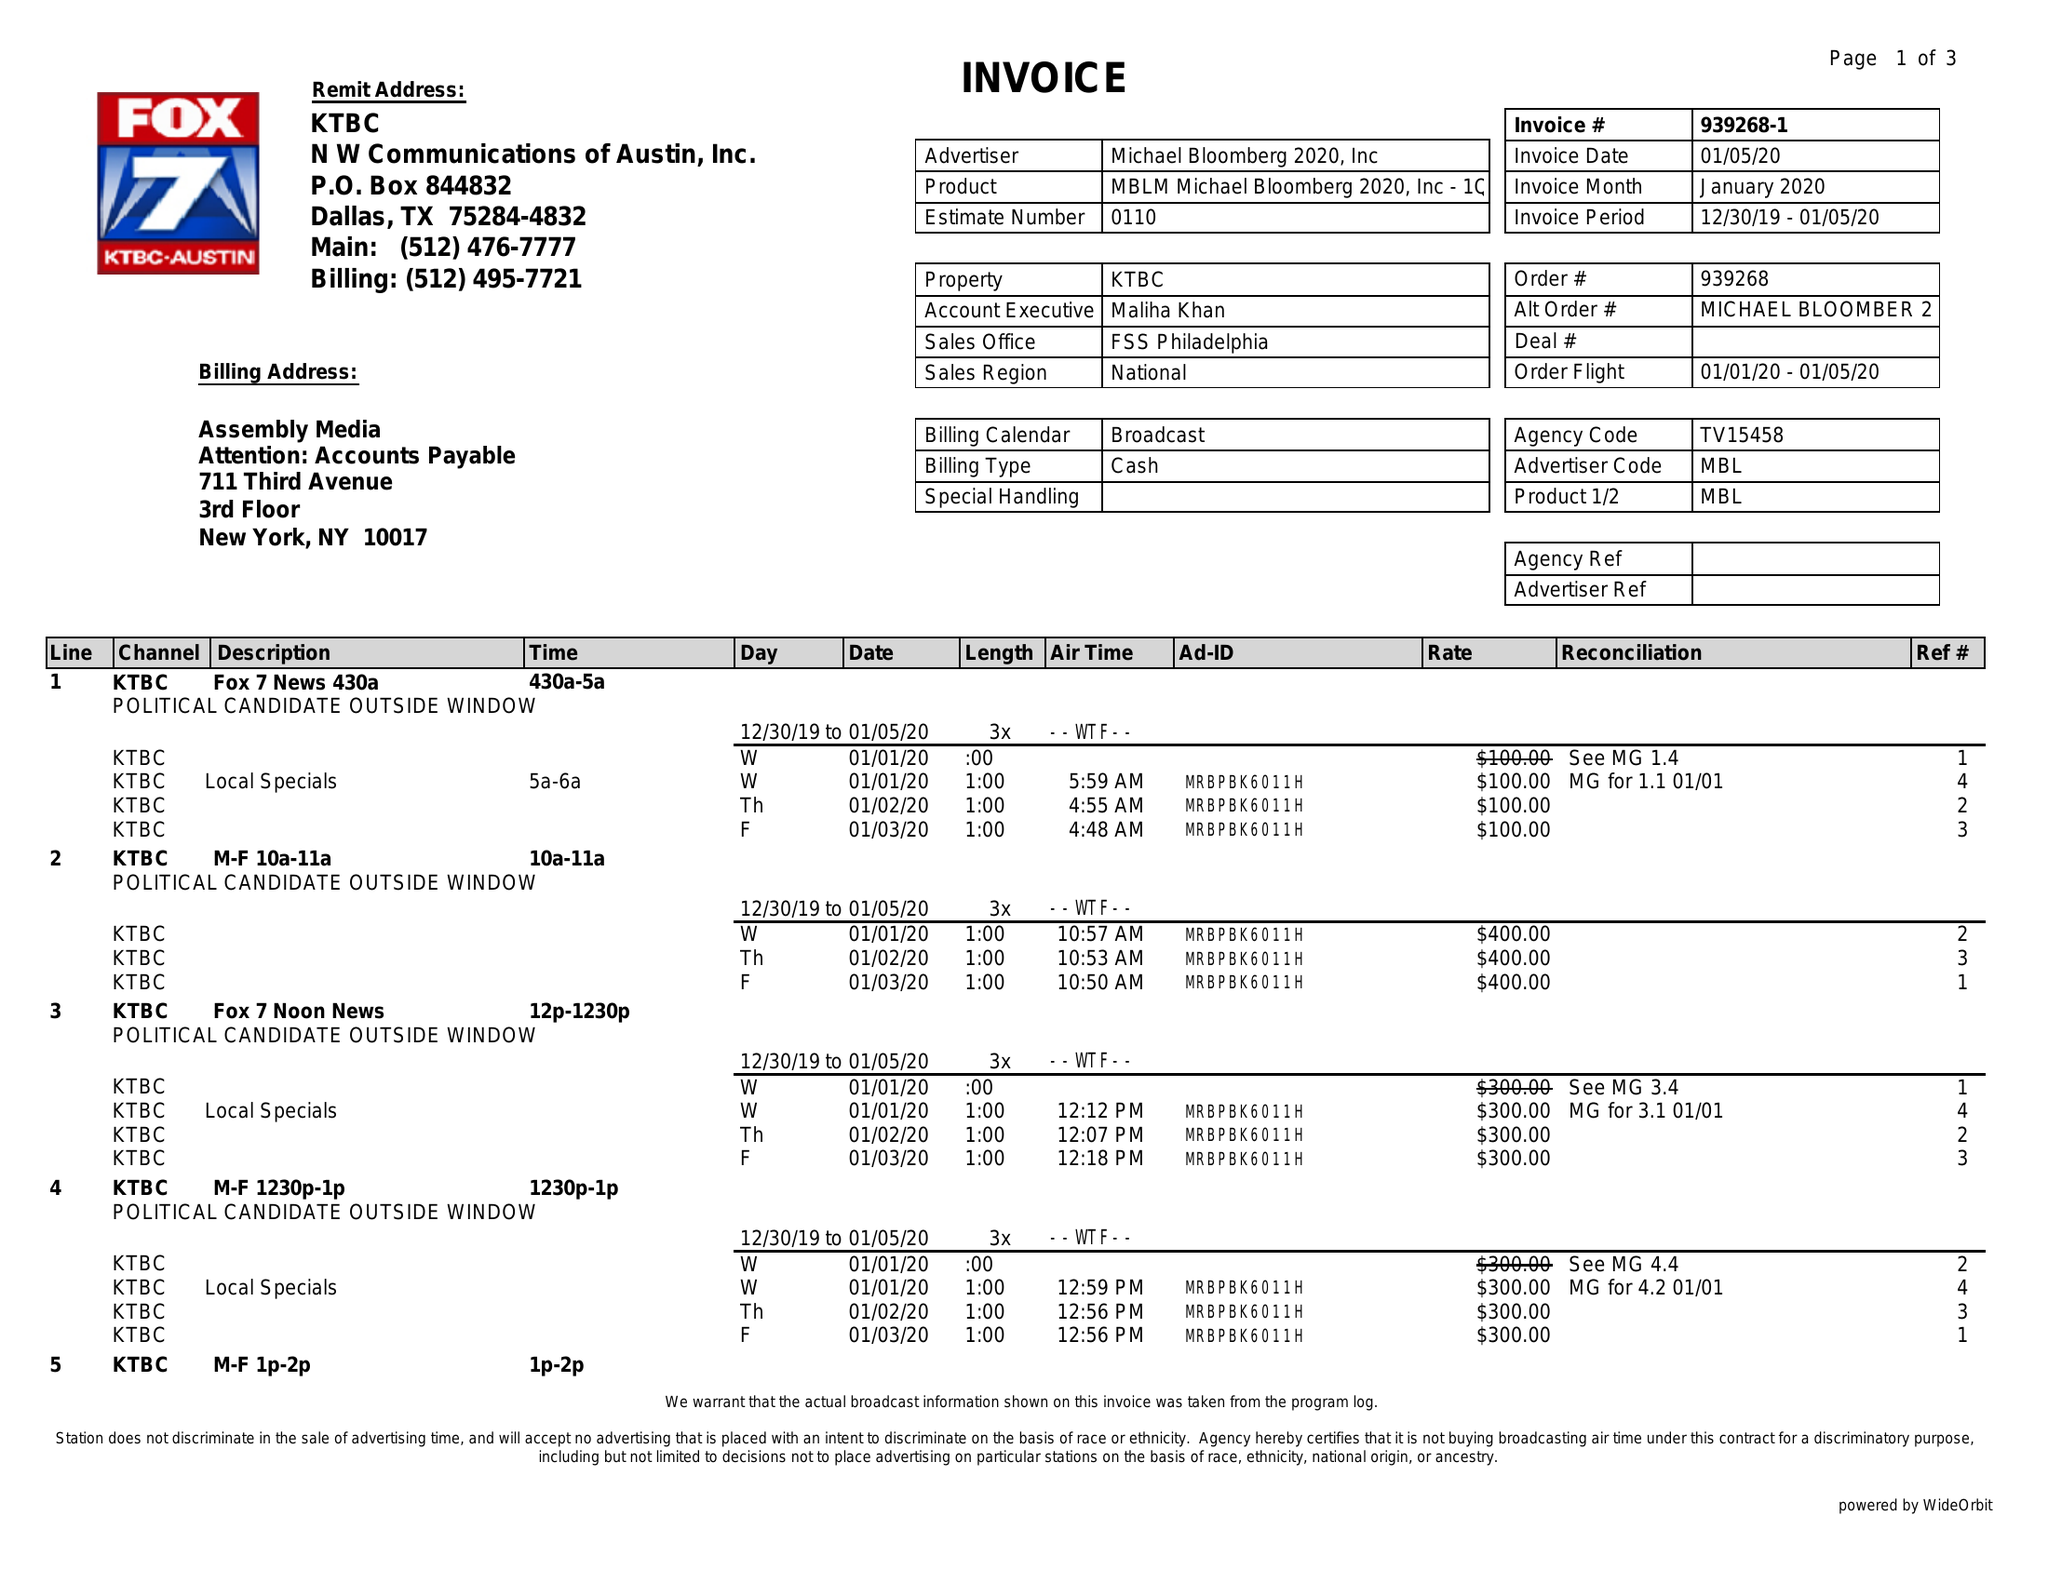What is the value for the advertiser?
Answer the question using a single word or phrase. MICHAEL BLOOMBERG 2020, INC 